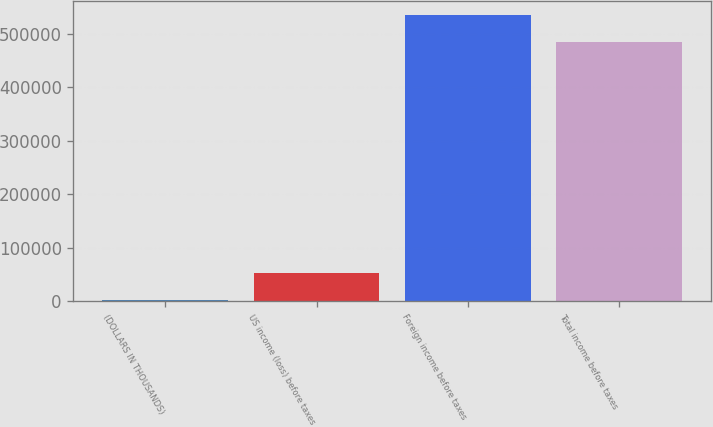Convert chart to OTSL. <chart><loc_0><loc_0><loc_500><loc_500><bar_chart><fcel>(DOLLARS IN THOUSANDS)<fcel>US income (loss) before taxes<fcel>Foreign income before taxes<fcel>Total income before taxes<nl><fcel>2013<fcel>52405.4<fcel>535602<fcel>485210<nl></chart> 